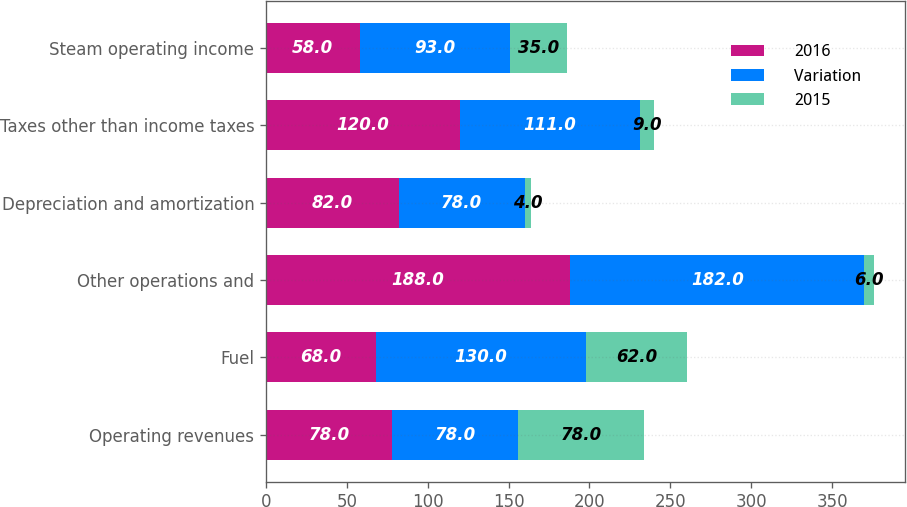Convert chart to OTSL. <chart><loc_0><loc_0><loc_500><loc_500><stacked_bar_chart><ecel><fcel>Operating revenues<fcel>Fuel<fcel>Other operations and<fcel>Depreciation and amortization<fcel>Taxes other than income taxes<fcel>Steam operating income<nl><fcel>2016<fcel>78<fcel>68<fcel>188<fcel>82<fcel>120<fcel>58<nl><fcel>Variation<fcel>78<fcel>130<fcel>182<fcel>78<fcel>111<fcel>93<nl><fcel>2015<fcel>78<fcel>62<fcel>6<fcel>4<fcel>9<fcel>35<nl></chart> 